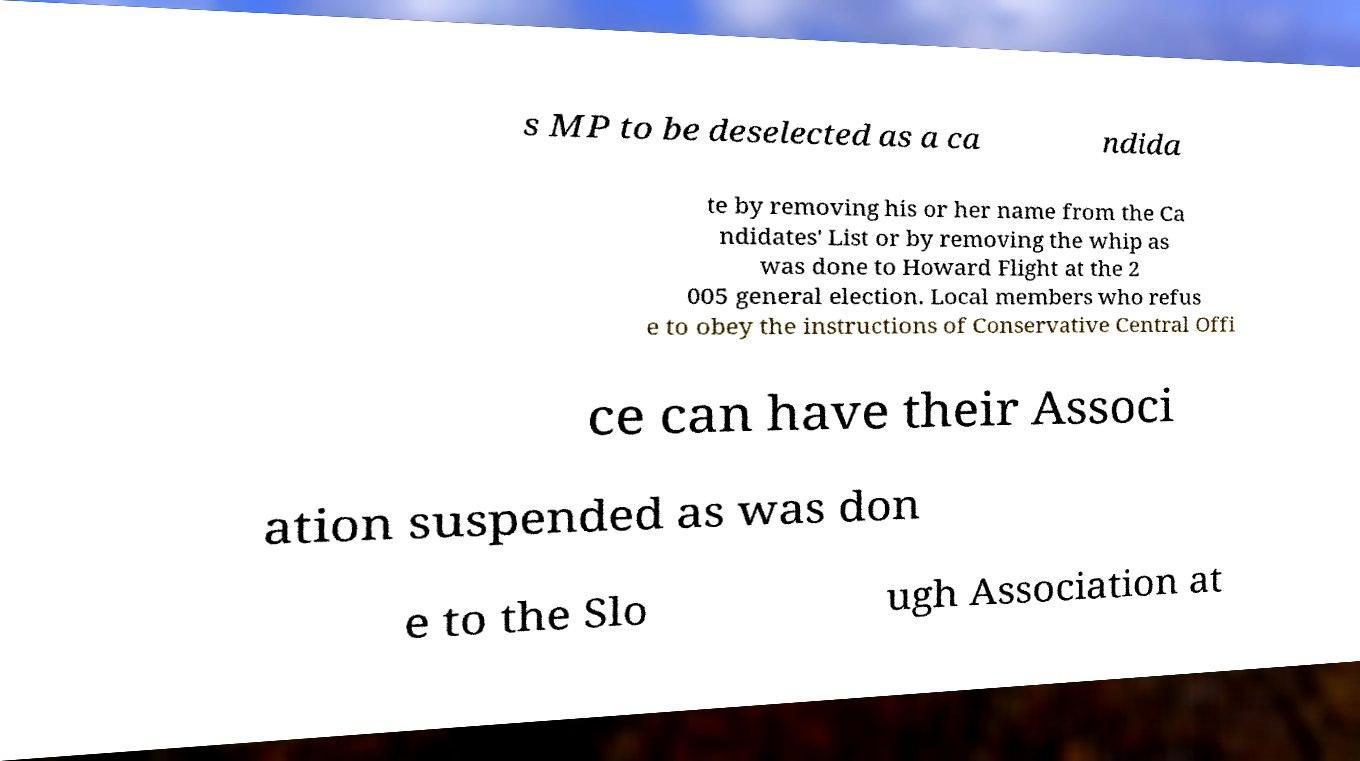I need the written content from this picture converted into text. Can you do that? s MP to be deselected as a ca ndida te by removing his or her name from the Ca ndidates' List or by removing the whip as was done to Howard Flight at the 2 005 general election. Local members who refus e to obey the instructions of Conservative Central Offi ce can have their Associ ation suspended as was don e to the Slo ugh Association at 